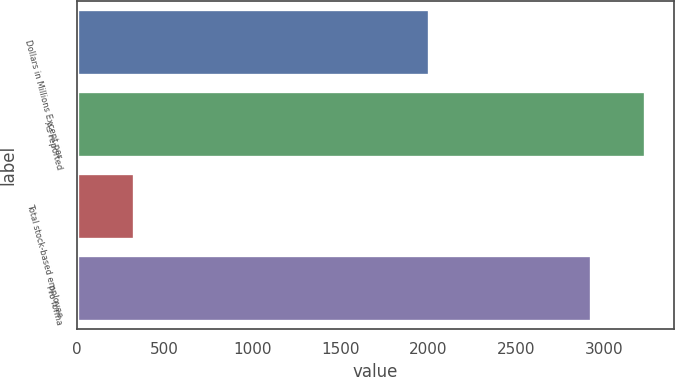Convert chart. <chart><loc_0><loc_0><loc_500><loc_500><bar_chart><fcel>Dollars in Millions Except per<fcel>As reported<fcel>Total stock-based employee<fcel>Pro forma<nl><fcel>2003<fcel>3234.2<fcel>323.2<fcel>2925<nl></chart> 